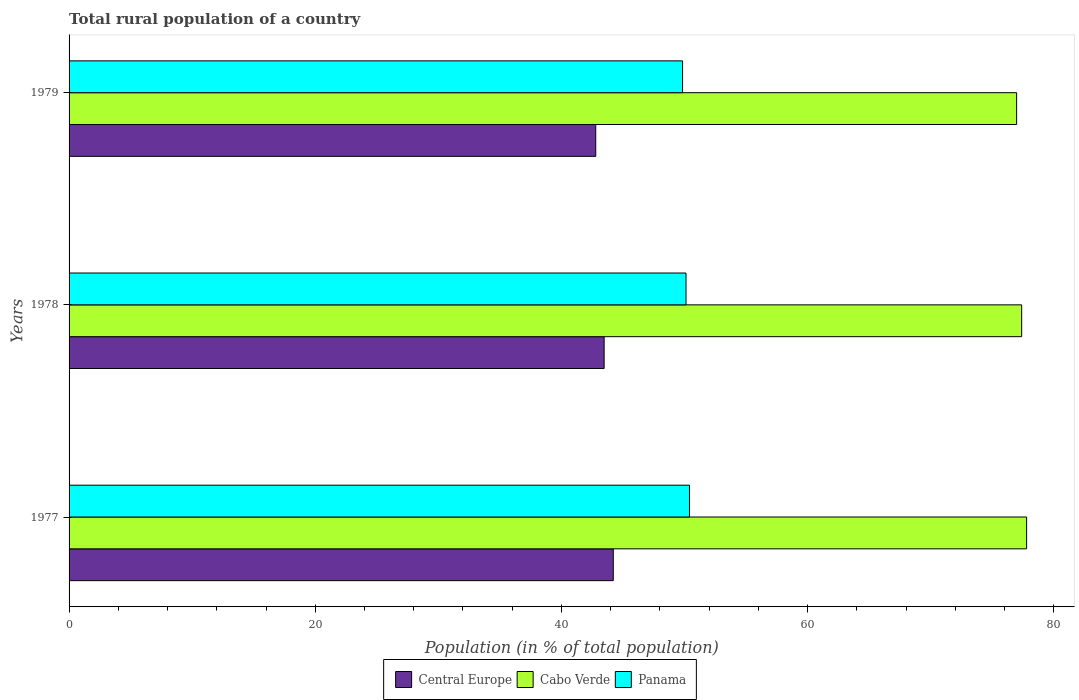How many different coloured bars are there?
Provide a succinct answer. 3. How many groups of bars are there?
Give a very brief answer. 3. Are the number of bars per tick equal to the number of legend labels?
Provide a short and direct response. Yes. Are the number of bars on each tick of the Y-axis equal?
Provide a succinct answer. Yes. How many bars are there on the 2nd tick from the top?
Give a very brief answer. 3. In how many cases, is the number of bars for a given year not equal to the number of legend labels?
Your answer should be compact. 0. What is the rural population in Panama in 1979?
Offer a terse response. 49.84. Across all years, what is the maximum rural population in Panama?
Your response must be concise. 50.4. Across all years, what is the minimum rural population in Cabo Verde?
Give a very brief answer. 76.98. In which year was the rural population in Cabo Verde maximum?
Provide a short and direct response. 1977. In which year was the rural population in Panama minimum?
Keep it short and to the point. 1979. What is the total rural population in Cabo Verde in the graph?
Provide a short and direct response. 232.16. What is the difference between the rural population in Panama in 1977 and that in 1979?
Provide a succinct answer. 0.56. What is the difference between the rural population in Panama in 1978 and the rural population in Central Europe in 1977?
Offer a terse response. 5.91. What is the average rural population in Central Europe per year?
Give a very brief answer. 43.49. In the year 1977, what is the difference between the rural population in Central Europe and rural population in Panama?
Your response must be concise. -6.19. In how many years, is the rural population in Central Europe greater than 44 %?
Keep it short and to the point. 1. What is the ratio of the rural population in Cabo Verde in 1978 to that in 1979?
Provide a short and direct response. 1.01. Is the rural population in Central Europe in 1977 less than that in 1978?
Your answer should be very brief. No. What is the difference between the highest and the second highest rural population in Cabo Verde?
Provide a succinct answer. 0.4. What is the difference between the highest and the lowest rural population in Central Europe?
Your response must be concise. 1.42. In how many years, is the rural population in Panama greater than the average rural population in Panama taken over all years?
Offer a terse response. 1. What does the 3rd bar from the top in 1978 represents?
Offer a terse response. Central Europe. What does the 3rd bar from the bottom in 1978 represents?
Make the answer very short. Panama. Is it the case that in every year, the sum of the rural population in Cabo Verde and rural population in Panama is greater than the rural population in Central Europe?
Keep it short and to the point. Yes. How many bars are there?
Your response must be concise. 9. What is the difference between two consecutive major ticks on the X-axis?
Your response must be concise. 20. Are the values on the major ticks of X-axis written in scientific E-notation?
Your answer should be compact. No. Does the graph contain any zero values?
Your response must be concise. No. Does the graph contain grids?
Offer a terse response. No. Where does the legend appear in the graph?
Your answer should be compact. Bottom center. How many legend labels are there?
Your response must be concise. 3. What is the title of the graph?
Make the answer very short. Total rural population of a country. What is the label or title of the X-axis?
Your answer should be very brief. Population (in % of total population). What is the Population (in % of total population) of Central Europe in 1977?
Offer a very short reply. 44.21. What is the Population (in % of total population) of Cabo Verde in 1977?
Your answer should be very brief. 77.79. What is the Population (in % of total population) of Panama in 1977?
Your answer should be very brief. 50.4. What is the Population (in % of total population) in Central Europe in 1978?
Make the answer very short. 43.47. What is the Population (in % of total population) of Cabo Verde in 1978?
Your answer should be compact. 77.39. What is the Population (in % of total population) of Panama in 1978?
Your answer should be very brief. 50.12. What is the Population (in % of total population) in Central Europe in 1979?
Offer a terse response. 42.79. What is the Population (in % of total population) in Cabo Verde in 1979?
Provide a succinct answer. 76.98. What is the Population (in % of total population) in Panama in 1979?
Your response must be concise. 49.84. Across all years, what is the maximum Population (in % of total population) of Central Europe?
Give a very brief answer. 44.21. Across all years, what is the maximum Population (in % of total population) of Cabo Verde?
Give a very brief answer. 77.79. Across all years, what is the maximum Population (in % of total population) in Panama?
Ensure brevity in your answer.  50.4. Across all years, what is the minimum Population (in % of total population) in Central Europe?
Make the answer very short. 42.79. Across all years, what is the minimum Population (in % of total population) of Cabo Verde?
Your answer should be compact. 76.98. Across all years, what is the minimum Population (in % of total population) in Panama?
Provide a short and direct response. 49.84. What is the total Population (in % of total population) in Central Europe in the graph?
Give a very brief answer. 130.47. What is the total Population (in % of total population) of Cabo Verde in the graph?
Offer a very short reply. 232.16. What is the total Population (in % of total population) in Panama in the graph?
Your answer should be very brief. 150.36. What is the difference between the Population (in % of total population) of Central Europe in 1977 and that in 1978?
Your answer should be compact. 0.74. What is the difference between the Population (in % of total population) of Cabo Verde in 1977 and that in 1978?
Give a very brief answer. 0.4. What is the difference between the Population (in % of total population) of Panama in 1977 and that in 1978?
Provide a short and direct response. 0.28. What is the difference between the Population (in % of total population) in Central Europe in 1977 and that in 1979?
Offer a terse response. 1.42. What is the difference between the Population (in % of total population) of Cabo Verde in 1977 and that in 1979?
Make the answer very short. 0.81. What is the difference between the Population (in % of total population) of Panama in 1977 and that in 1979?
Your answer should be compact. 0.56. What is the difference between the Population (in % of total population) of Central Europe in 1978 and that in 1979?
Your response must be concise. 0.68. What is the difference between the Population (in % of total population) in Cabo Verde in 1978 and that in 1979?
Offer a terse response. 0.41. What is the difference between the Population (in % of total population) of Panama in 1978 and that in 1979?
Give a very brief answer. 0.28. What is the difference between the Population (in % of total population) in Central Europe in 1977 and the Population (in % of total population) in Cabo Verde in 1978?
Your response must be concise. -33.18. What is the difference between the Population (in % of total population) in Central Europe in 1977 and the Population (in % of total population) in Panama in 1978?
Ensure brevity in your answer.  -5.91. What is the difference between the Population (in % of total population) of Cabo Verde in 1977 and the Population (in % of total population) of Panama in 1978?
Provide a succinct answer. 27.67. What is the difference between the Population (in % of total population) in Central Europe in 1977 and the Population (in % of total population) in Cabo Verde in 1979?
Give a very brief answer. -32.77. What is the difference between the Population (in % of total population) of Central Europe in 1977 and the Population (in % of total population) of Panama in 1979?
Keep it short and to the point. -5.63. What is the difference between the Population (in % of total population) in Cabo Verde in 1977 and the Population (in % of total population) in Panama in 1979?
Your answer should be compact. 27.95. What is the difference between the Population (in % of total population) in Central Europe in 1978 and the Population (in % of total population) in Cabo Verde in 1979?
Provide a succinct answer. -33.51. What is the difference between the Population (in % of total population) in Central Europe in 1978 and the Population (in % of total population) in Panama in 1979?
Give a very brief answer. -6.37. What is the difference between the Population (in % of total population) in Cabo Verde in 1978 and the Population (in % of total population) in Panama in 1979?
Provide a succinct answer. 27.55. What is the average Population (in % of total population) of Central Europe per year?
Offer a terse response. 43.49. What is the average Population (in % of total population) in Cabo Verde per year?
Provide a short and direct response. 77.39. What is the average Population (in % of total population) of Panama per year?
Your answer should be compact. 50.12. In the year 1977, what is the difference between the Population (in % of total population) in Central Europe and Population (in % of total population) in Cabo Verde?
Make the answer very short. -33.58. In the year 1977, what is the difference between the Population (in % of total population) in Central Europe and Population (in % of total population) in Panama?
Provide a succinct answer. -6.19. In the year 1977, what is the difference between the Population (in % of total population) in Cabo Verde and Population (in % of total population) in Panama?
Offer a very short reply. 27.39. In the year 1978, what is the difference between the Population (in % of total population) in Central Europe and Population (in % of total population) in Cabo Verde?
Provide a short and direct response. -33.92. In the year 1978, what is the difference between the Population (in % of total population) of Central Europe and Population (in % of total population) of Panama?
Keep it short and to the point. -6.65. In the year 1978, what is the difference between the Population (in % of total population) of Cabo Verde and Population (in % of total population) of Panama?
Make the answer very short. 27.27. In the year 1979, what is the difference between the Population (in % of total population) of Central Europe and Population (in % of total population) of Cabo Verde?
Your response must be concise. -34.19. In the year 1979, what is the difference between the Population (in % of total population) in Central Europe and Population (in % of total population) in Panama?
Your answer should be very brief. -7.05. In the year 1979, what is the difference between the Population (in % of total population) in Cabo Verde and Population (in % of total population) in Panama?
Your response must be concise. 27.14. What is the ratio of the Population (in % of total population) of Central Europe in 1977 to that in 1978?
Make the answer very short. 1.02. What is the ratio of the Population (in % of total population) of Cabo Verde in 1977 to that in 1978?
Make the answer very short. 1.01. What is the ratio of the Population (in % of total population) of Panama in 1977 to that in 1978?
Make the answer very short. 1.01. What is the ratio of the Population (in % of total population) in Cabo Verde in 1977 to that in 1979?
Offer a terse response. 1.01. What is the ratio of the Population (in % of total population) of Panama in 1977 to that in 1979?
Your response must be concise. 1.01. What is the ratio of the Population (in % of total population) in Cabo Verde in 1978 to that in 1979?
Your response must be concise. 1.01. What is the ratio of the Population (in % of total population) in Panama in 1978 to that in 1979?
Offer a terse response. 1.01. What is the difference between the highest and the second highest Population (in % of total population) in Central Europe?
Your answer should be very brief. 0.74. What is the difference between the highest and the second highest Population (in % of total population) of Cabo Verde?
Keep it short and to the point. 0.4. What is the difference between the highest and the second highest Population (in % of total population) of Panama?
Your answer should be compact. 0.28. What is the difference between the highest and the lowest Population (in % of total population) in Central Europe?
Keep it short and to the point. 1.42. What is the difference between the highest and the lowest Population (in % of total population) in Cabo Verde?
Give a very brief answer. 0.81. What is the difference between the highest and the lowest Population (in % of total population) in Panama?
Make the answer very short. 0.56. 